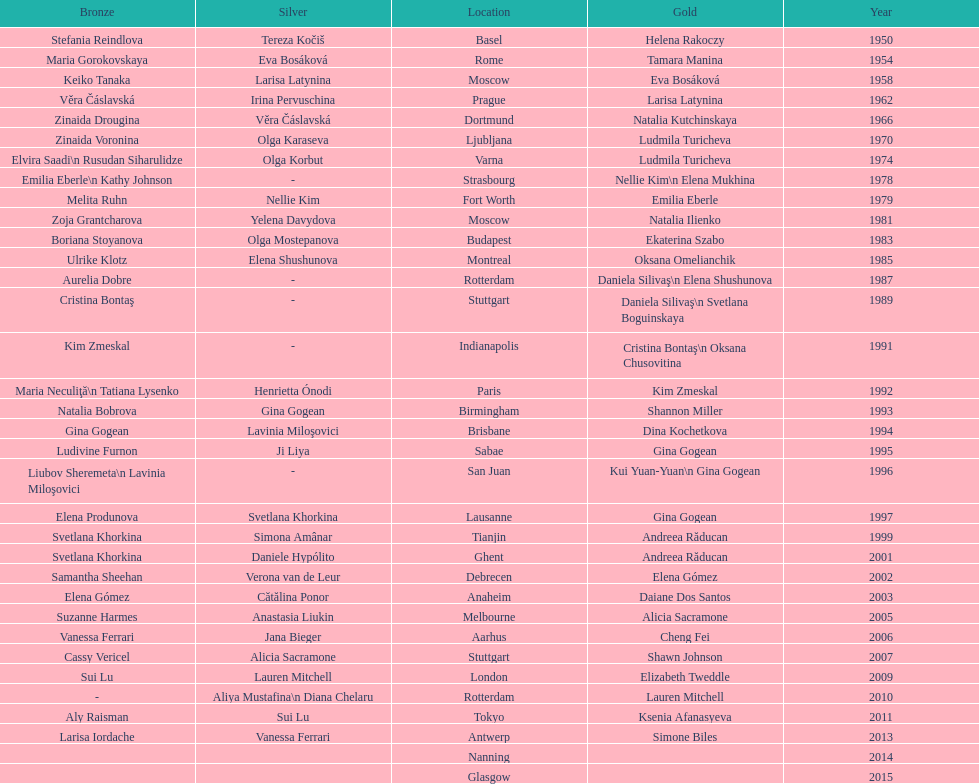How long is the time between the times the championship was held in moscow? 23 years. 